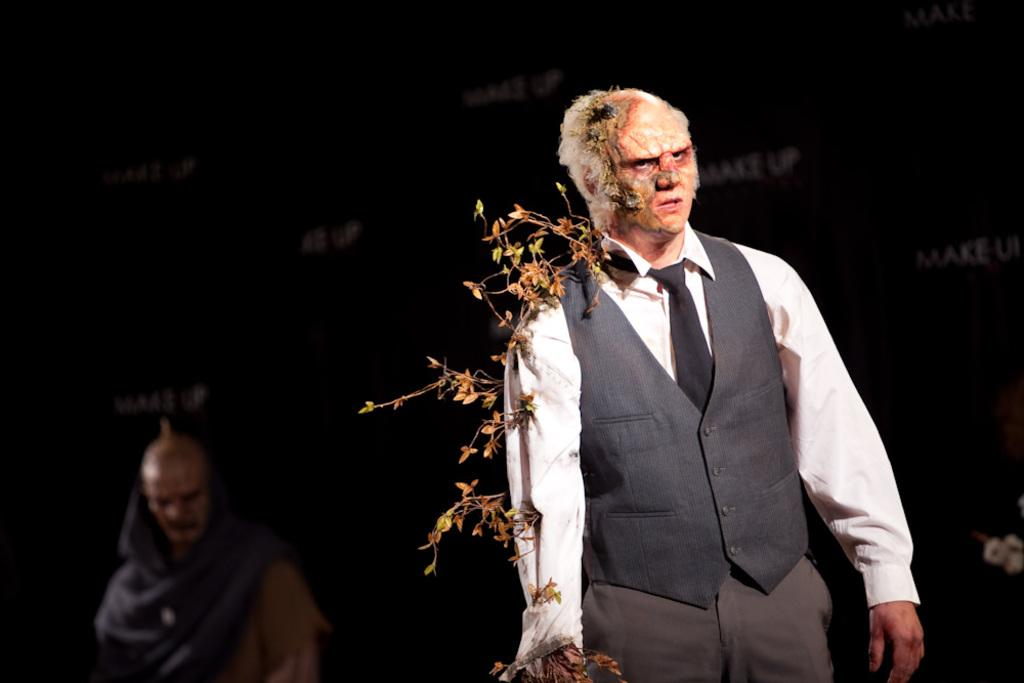What is the position of the man in the image? There is a man on the right side of the image. What is the man wearing? The man is wearing a suit and a tie. What is the man holding in his right hand? The man is holding a plant in his right hand. Can you describe the other man in the image? There is another man on the left side of the image. What type of insect can be seen coiled around the man's tie in the image? There is no insect present in the image, and the man's tie is not coiled around anything. 